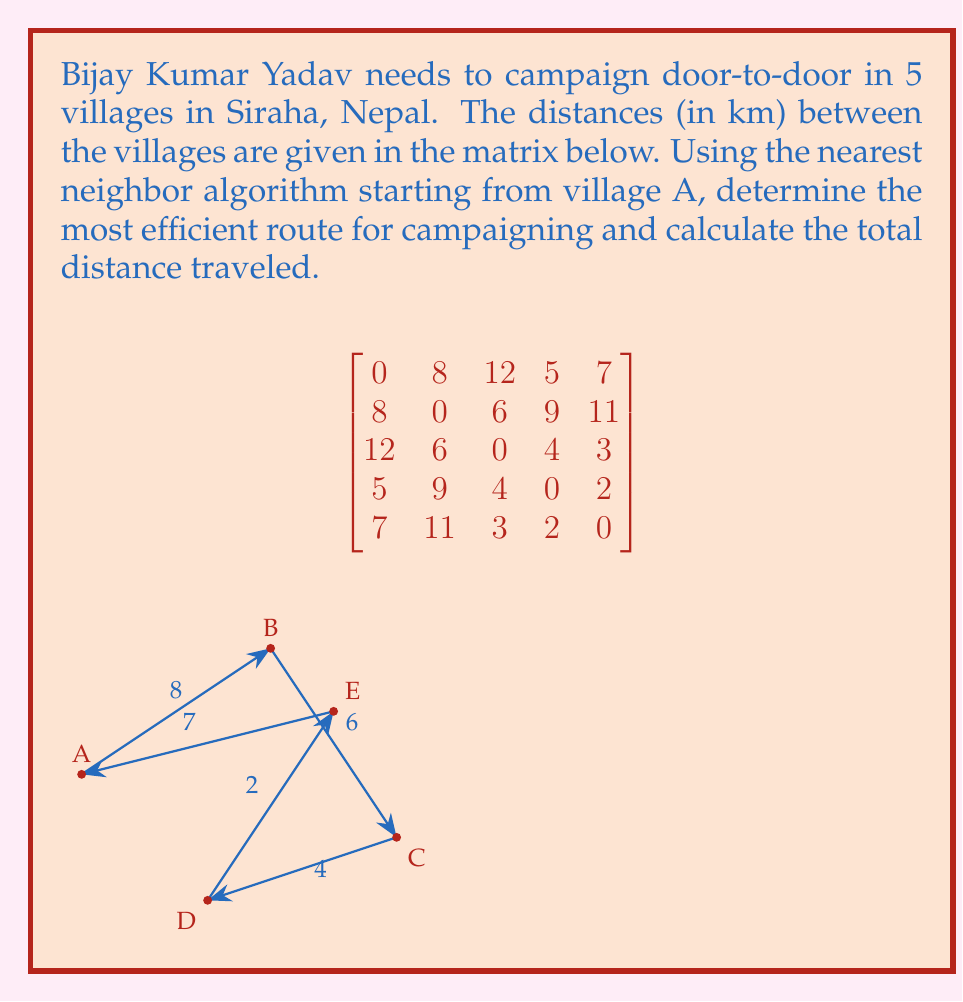Solve this math problem. Let's apply the nearest neighbor algorithm starting from village A:

1) Start at A:
   - Distances from A: B(8), C(12), D(5), E(7)
   - Nearest neighbor is D (5 km)
   - Route: A → D

2) At D:
   - Distances from D: B(9), C(4), E(2)
   - Nearest neighbor is E (2 km)
   - Route: A → D → E

3) At E:
   - Distances from E: B(11), C(3)
   - Nearest neighbor is C (3 km)
   - Route: A → D → E → C

4) At C:
   - Distance to B: 6 km
   - Only B is left, so we go there
   - Route: A → D → E → C → B

5) Return to A:
   - Distance from B to A: 8 km
   - Final route: A → D → E → C → B → A

Calculate total distance:
$$\text{Total} = AD + DE + EC + CB + BA$$
$$\text{Total} = 5 + 2 + 3 + 6 + 8 = 24 \text{ km}$$
Answer: Route: A → D → E → C → B → A; Total distance: 24 km 